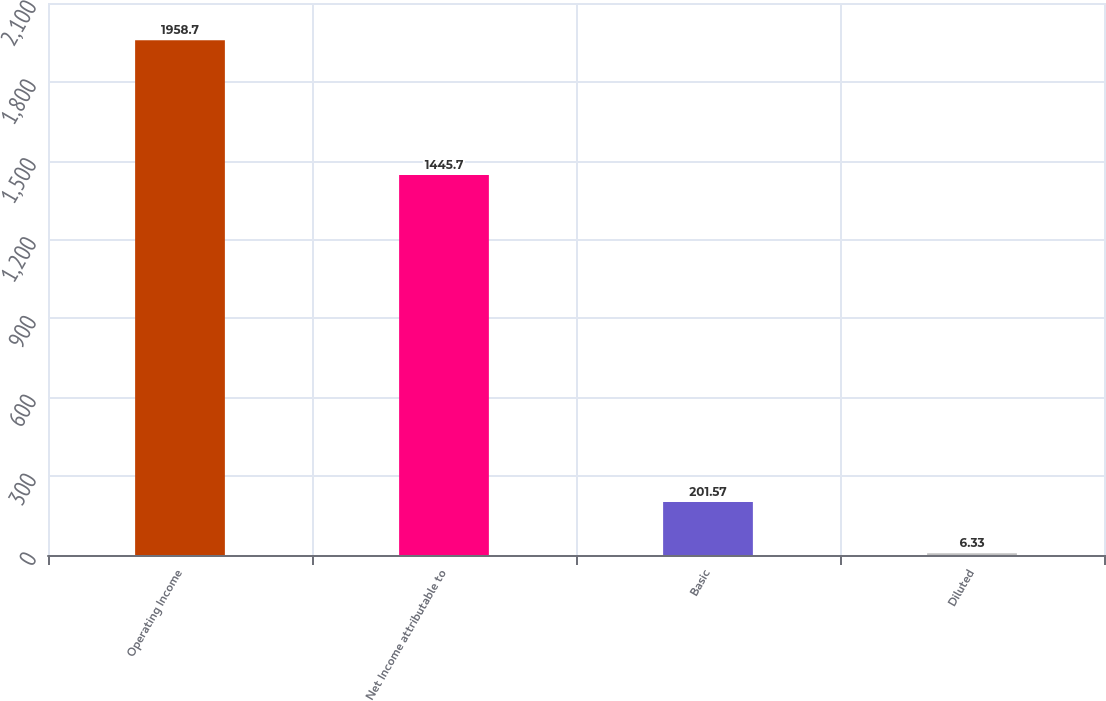Convert chart. <chart><loc_0><loc_0><loc_500><loc_500><bar_chart><fcel>Operating Income<fcel>Net Income attributable to<fcel>Basic<fcel>Diluted<nl><fcel>1958.7<fcel>1445.7<fcel>201.57<fcel>6.33<nl></chart> 